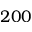<formula> <loc_0><loc_0><loc_500><loc_500>2 0 0</formula> 